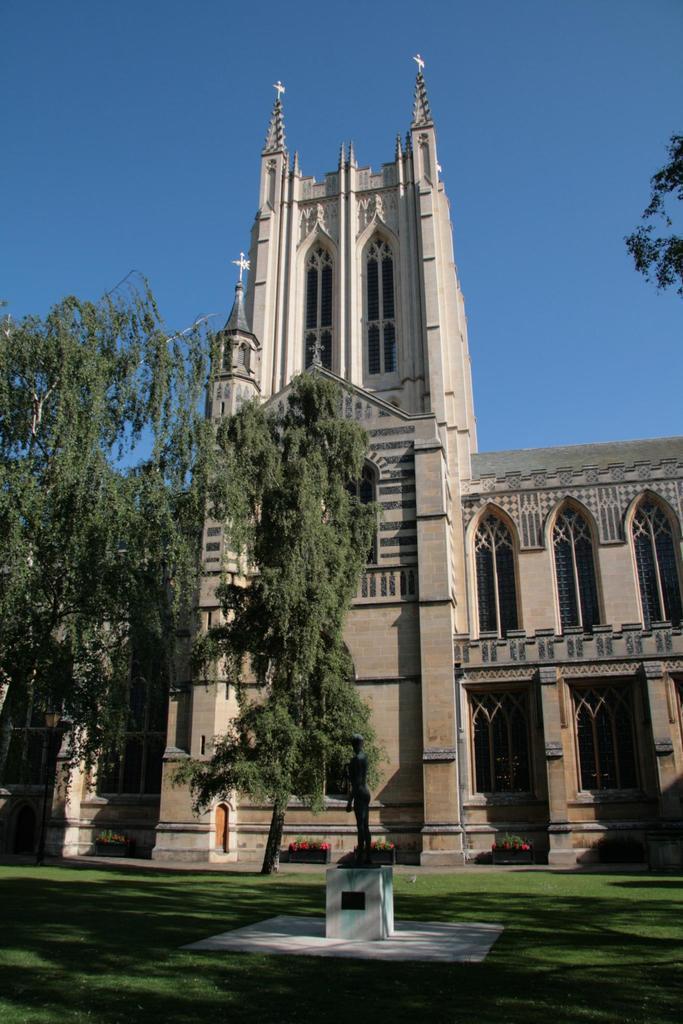Please provide a concise description of this image. In this image, we can see some trees in front of the building. There is a sky at the top of the image. There is a branch in the top right of the image. 